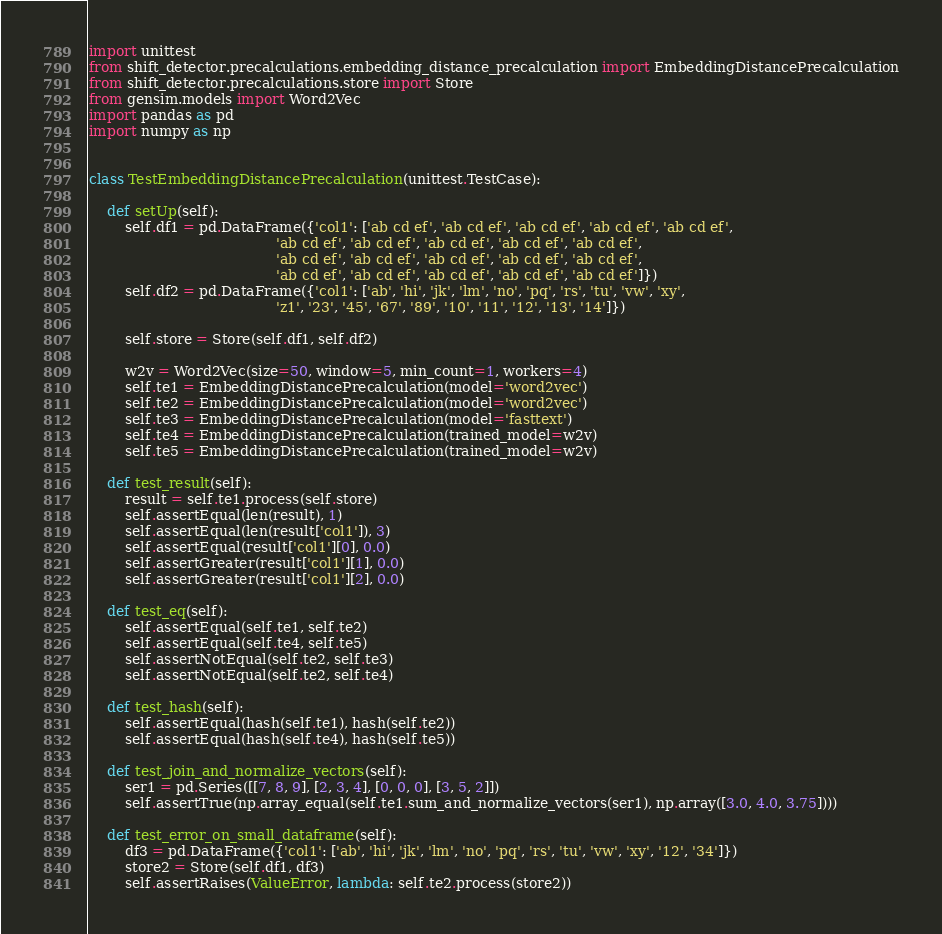<code> <loc_0><loc_0><loc_500><loc_500><_Python_>import unittest
from shift_detector.precalculations.embedding_distance_precalculation import EmbeddingDistancePrecalculation
from shift_detector.precalculations.store import Store
from gensim.models import Word2Vec
import pandas as pd
import numpy as np


class TestEmbeddingDistancePrecalculation(unittest.TestCase):

    def setUp(self):
        self.df1 = pd.DataFrame({'col1': ['ab cd ef', 'ab cd ef', 'ab cd ef', 'ab cd ef', 'ab cd ef',
                                          'ab cd ef', 'ab cd ef', 'ab cd ef', 'ab cd ef', 'ab cd ef',
                                          'ab cd ef', 'ab cd ef', 'ab cd ef', 'ab cd ef', 'ab cd ef',
                                          'ab cd ef', 'ab cd ef', 'ab cd ef', 'ab cd ef', 'ab cd ef']})
        self.df2 = pd.DataFrame({'col1': ['ab', 'hi', 'jk', 'lm', 'no', 'pq', 'rs', 'tu', 'vw', 'xy',
                                          'z1', '23', '45', '67', '89', '10', '11', '12', '13', '14']})

        self.store = Store(self.df1, self.df2)

        w2v = Word2Vec(size=50, window=5, min_count=1, workers=4)
        self.te1 = EmbeddingDistancePrecalculation(model='word2vec')
        self.te2 = EmbeddingDistancePrecalculation(model='word2vec')
        self.te3 = EmbeddingDistancePrecalculation(model='fasttext')
        self.te4 = EmbeddingDistancePrecalculation(trained_model=w2v)
        self.te5 = EmbeddingDistancePrecalculation(trained_model=w2v)

    def test_result(self):
        result = self.te1.process(self.store)
        self.assertEqual(len(result), 1)
        self.assertEqual(len(result['col1']), 3)
        self.assertEqual(result['col1'][0], 0.0)
        self.assertGreater(result['col1'][1], 0.0)
        self.assertGreater(result['col1'][2], 0.0)

    def test_eq(self):
        self.assertEqual(self.te1, self.te2)
        self.assertEqual(self.te4, self.te5)
        self.assertNotEqual(self.te2, self.te3)
        self.assertNotEqual(self.te2, self.te4)

    def test_hash(self):
        self.assertEqual(hash(self.te1), hash(self.te2))
        self.assertEqual(hash(self.te4), hash(self.te5))

    def test_join_and_normalize_vectors(self):
        ser1 = pd.Series([[7, 8, 9], [2, 3, 4], [0, 0, 0], [3, 5, 2]])
        self.assertTrue(np.array_equal(self.te1.sum_and_normalize_vectors(ser1), np.array([3.0, 4.0, 3.75])))

    def test_error_on_small_dataframe(self):
        df3 = pd.DataFrame({'col1': ['ab', 'hi', 'jk', 'lm', 'no', 'pq', 'rs', 'tu', 'vw', 'xy', '12', '34']})
        store2 = Store(self.df1, df3)
        self.assertRaises(ValueError, lambda: self.te2.process(store2))
</code> 